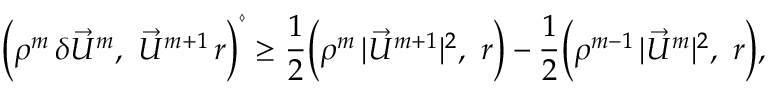<formula> <loc_0><loc_0><loc_500><loc_500>\left ( \rho ^ { m } \, \delta \vec { U } ^ { m } , \vec { U } ^ { m + 1 } \, r \right ) ^ { \diamond } \geq \frac { 1 } { 2 } \left ( \rho ^ { m } \, | \vec { U } ^ { m + 1 } | ^ { 2 } , r \right ) - \frac { 1 } { 2 } \left ( \rho ^ { m - 1 } \, | \vec { U } ^ { m } | ^ { 2 } , r \right ) ,</formula> 